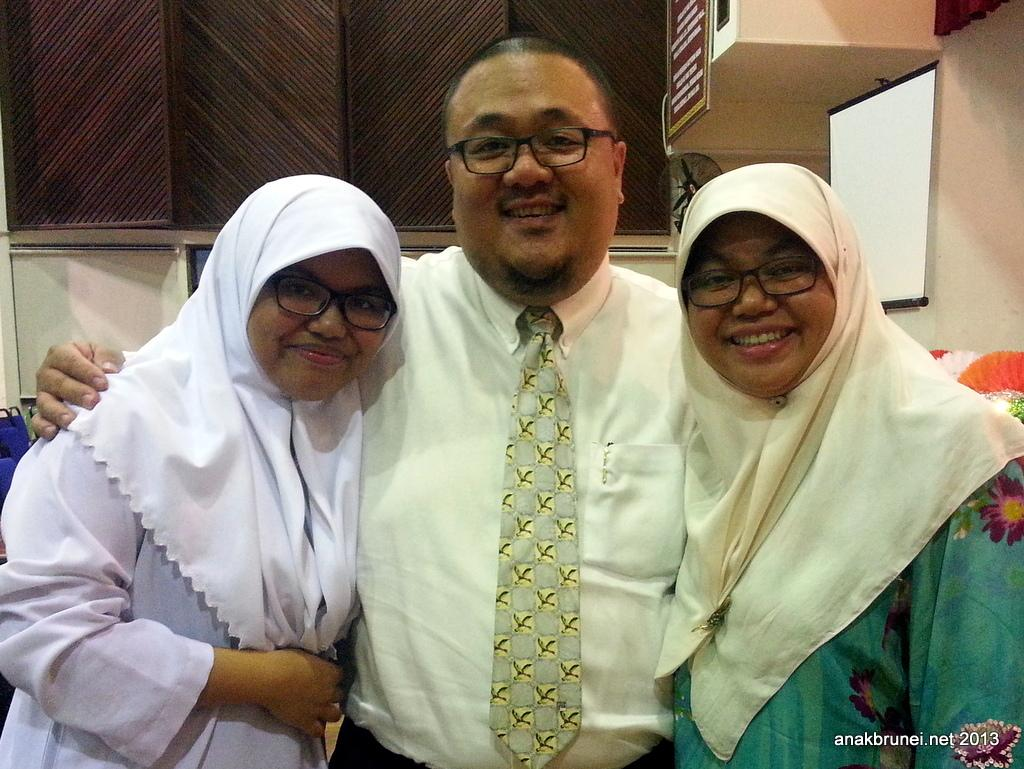How many people are present in the image? There are three persons standing in the image. Can you describe the background of the image? There are brown color cupboards in the background of the image. What type of dinosaurs can be seen in the image? There are no dinosaurs present in the image. What sound can be heard coming from the cupboards in the image? There is no sound coming from the cupboards in the image, as it is a still image. 